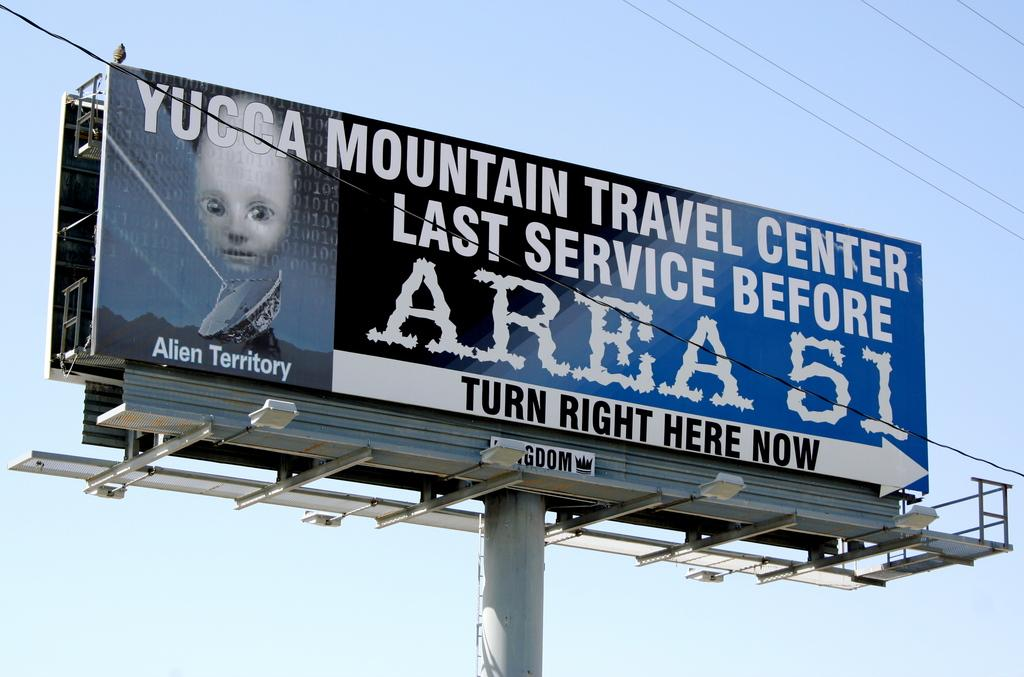<image>
Offer a succinct explanation of the picture presented. A billboard sign advertising Mountain Travel Center as the last service before area 51. 